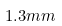<formula> <loc_0><loc_0><loc_500><loc_500>1 . 3 m m</formula> 